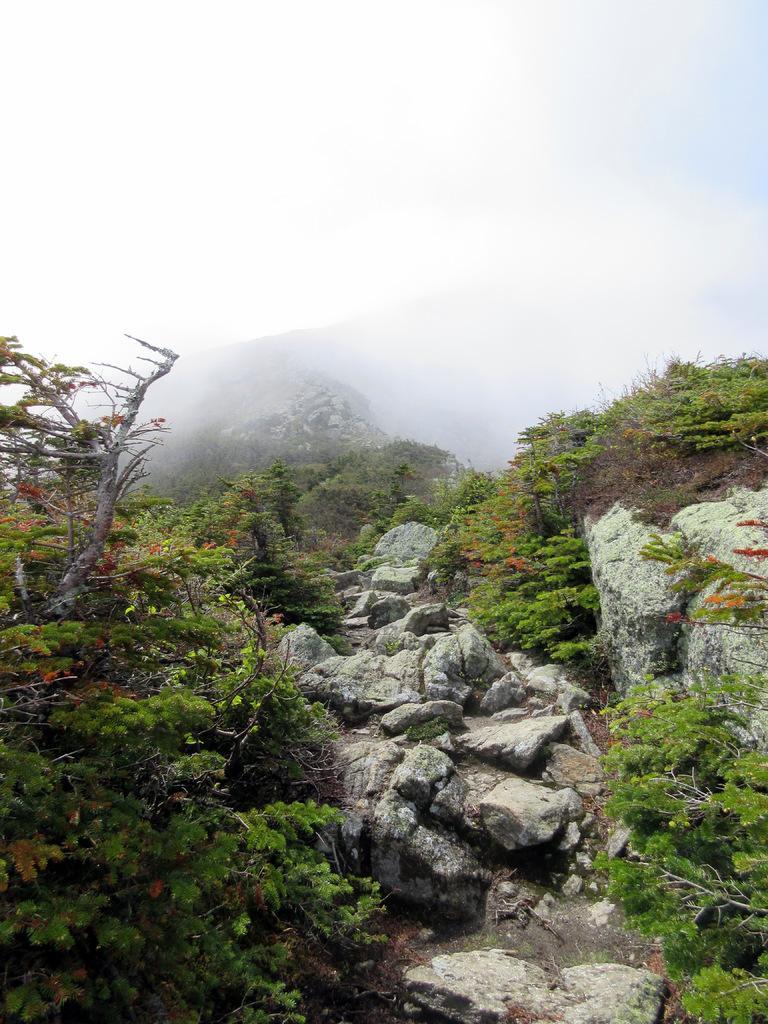In one or two sentences, can you explain what this image depicts? In this image we can see a tree and plants on the mountains. It seems like fog at the top of the image. 